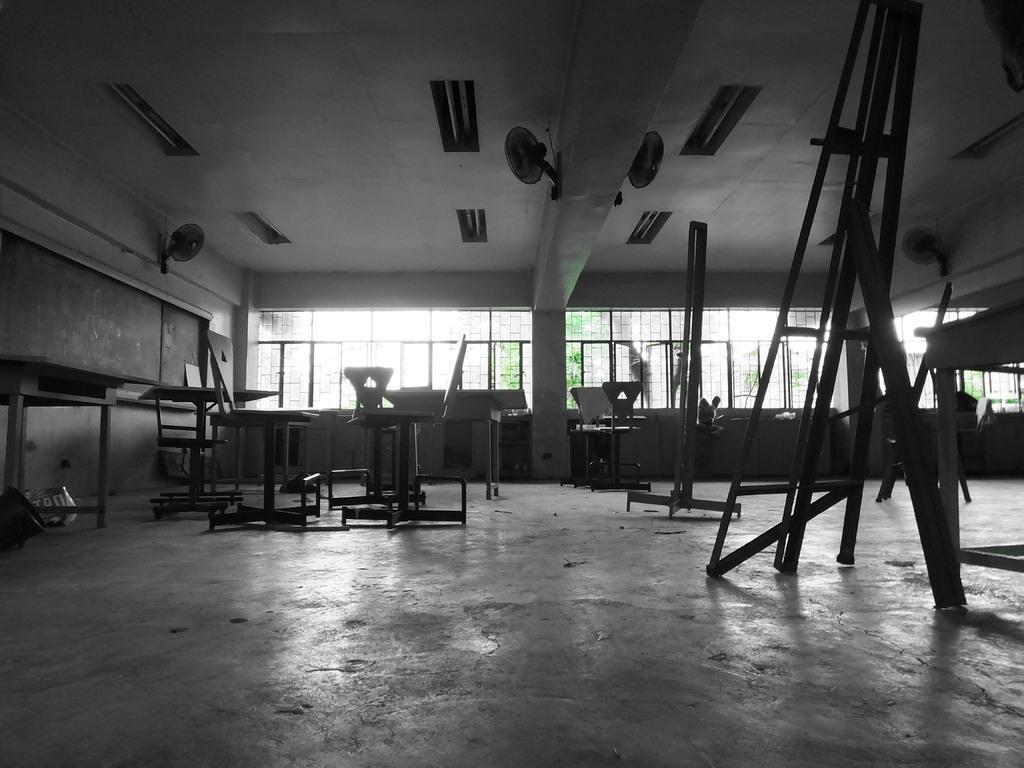Could you give a brief overview of what you see in this image? In this image I can see few benches on the floor. I can see few fans, few lights, the ceiling, the board and few windows through which I can see few trees. 